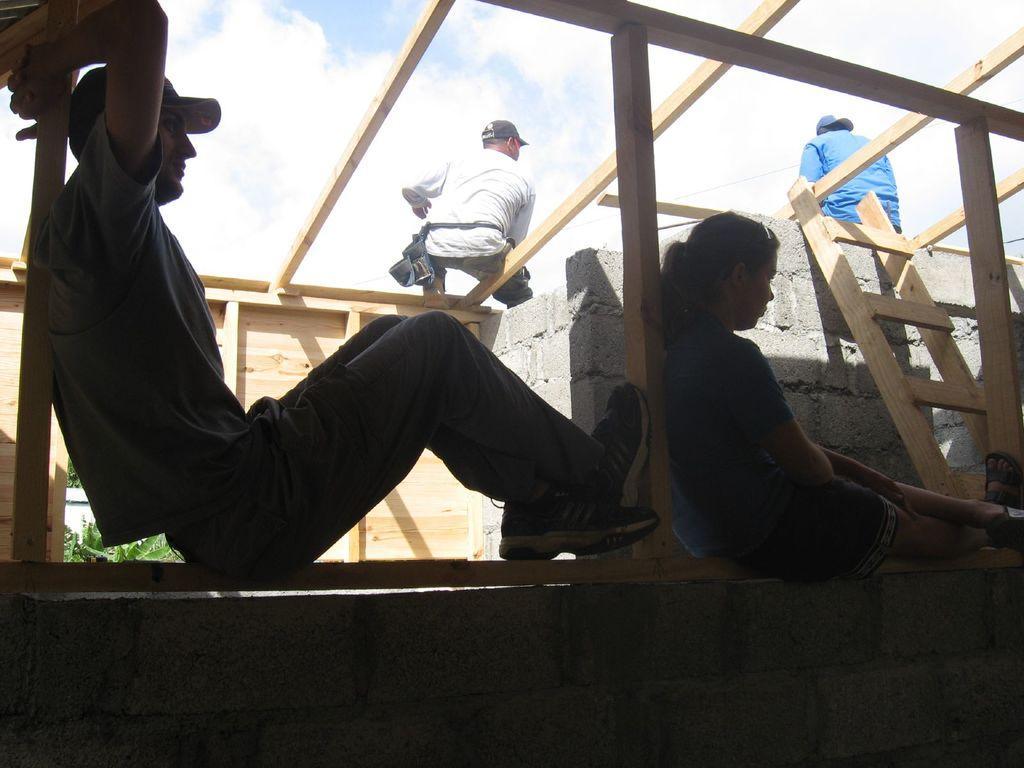Please provide a concise description of this image. At the bottom of the image we can see a wall, on the wall two persons are sitting. Beside them there is wall and steps, on the wall two persons are sitting. At the top of the image there are some clouds in the sky. Behind the wall there are some trees. 